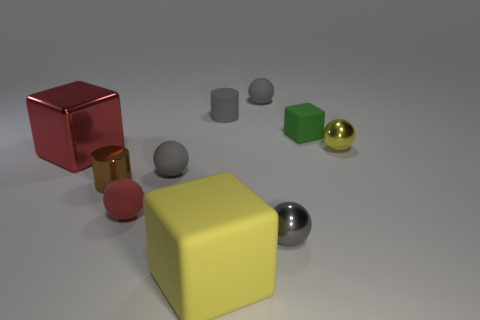How many gray balls must be subtracted to get 1 gray balls? 2 Subtract all gray cubes. How many gray balls are left? 3 Subtract all shiny balls. How many balls are left? 3 Subtract all red spheres. How many spheres are left? 4 Subtract all cylinders. How many objects are left? 8 Subtract all cyan cubes. Subtract all purple spheres. How many cubes are left? 3 Add 7 gray cylinders. How many gray cylinders are left? 8 Add 2 metallic cylinders. How many metallic cylinders exist? 3 Subtract 0 cyan spheres. How many objects are left? 10 Subtract all tiny gray spheres. Subtract all gray rubber cylinders. How many objects are left? 6 